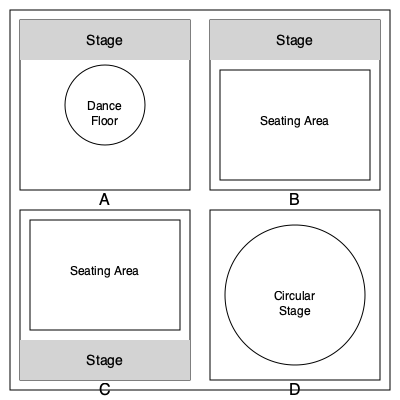Based on your experience in the Paris music scene of the 70s and 80s, which of these floor plan layouts (A, B, C, or D) would most likely represent a typical jazz club of that era? Let's analyze each layout to determine which one best represents a typical jazz club from the Paris music scene of the 70s and 80s:

1. Layout A: This layout features a stage at the top and a large central dance floor. While some jazz clubs might have space for dancing, a large central dance floor is more characteristic of disco or general nightclubs. This layout is not typical for a jazz club.

2. Layout B: This layout shows a stage at the top with a large seating area in front. This arrangement is common in jazz clubs, allowing patrons to sit and enjoy the music while facing the performers. The proximity of the seating to the stage creates an intimate atmosphere typical of jazz venues.

3. Layout C: Similar to Layout B, this design has a stage and seating area. However, the stage is at the bottom, which is less common. While not impossible for a jazz club, this layout is less typical than B.

4. Layout D: This layout features a circular stage in the center. While innovative, this design is more suited to theater-in-the-round concepts or avant-garde venues. It's not typical for traditional jazz clubs, especially from the 70s and 80s.

Considering the Paris jazz scene of the 70s and 80s, intimate venues with a clear focus on the music were prevalent. Jazz clubs typically prioritized seating arrangements that allowed patrons to watch and listen to the performers comfortably.

Based on this analysis, Layout B most closely resembles a typical jazz club layout from that era. It provides an optimal setup for both musicians and audience, creating the intimate atmosphere characteristic of jazz performances.
Answer: B 